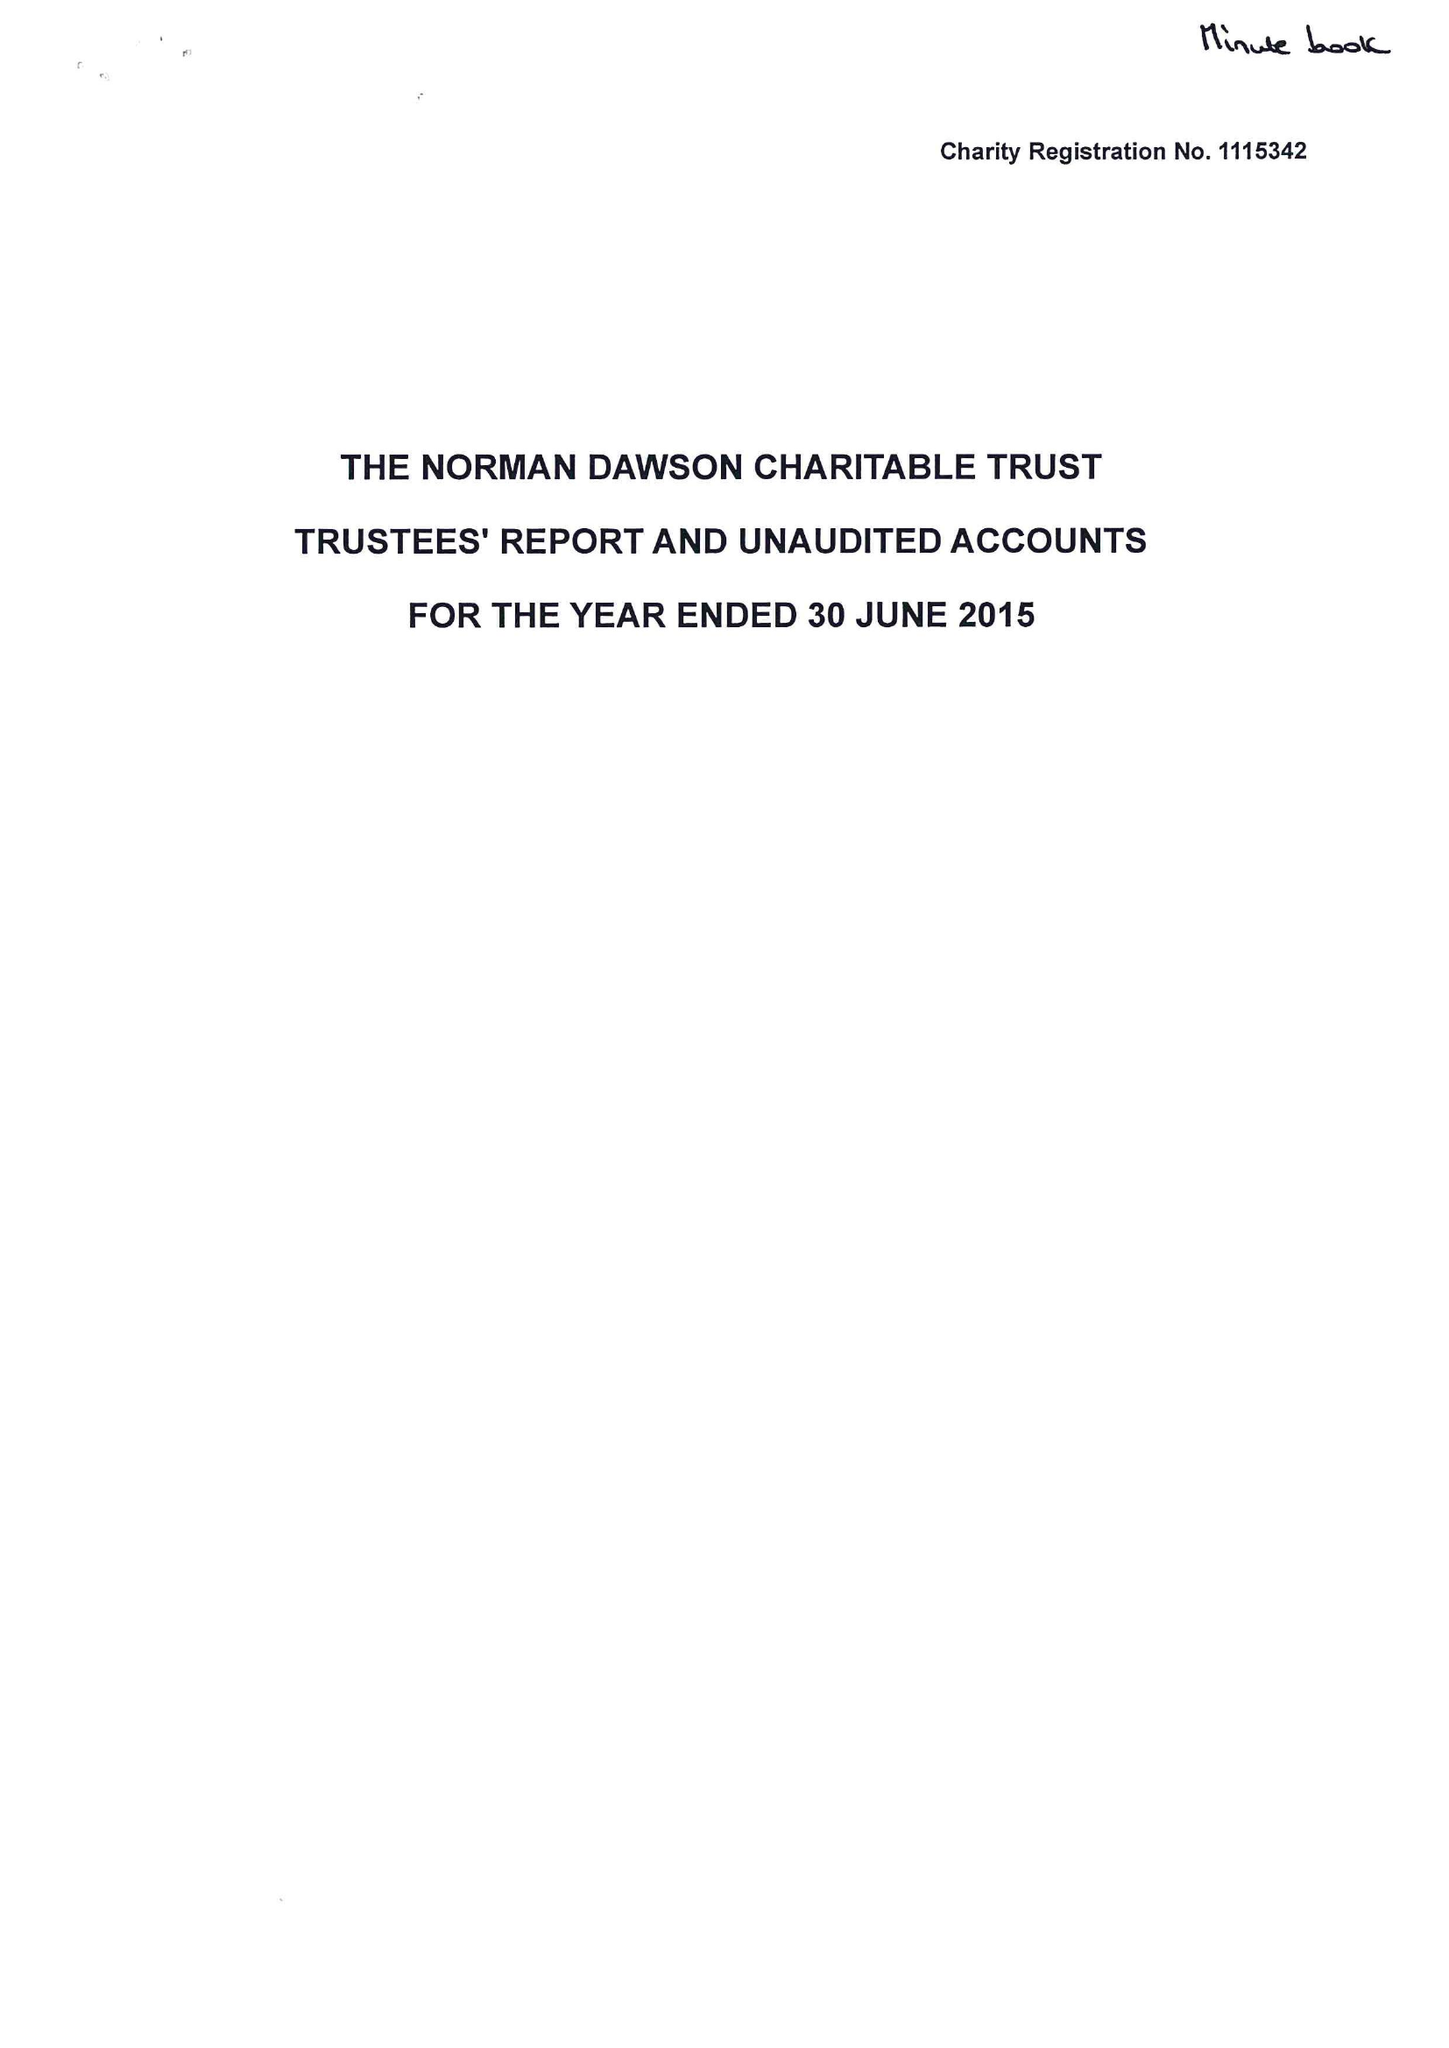What is the value for the charity_name?
Answer the question using a single word or phrase. The Norman Dawson Charitable Trust 